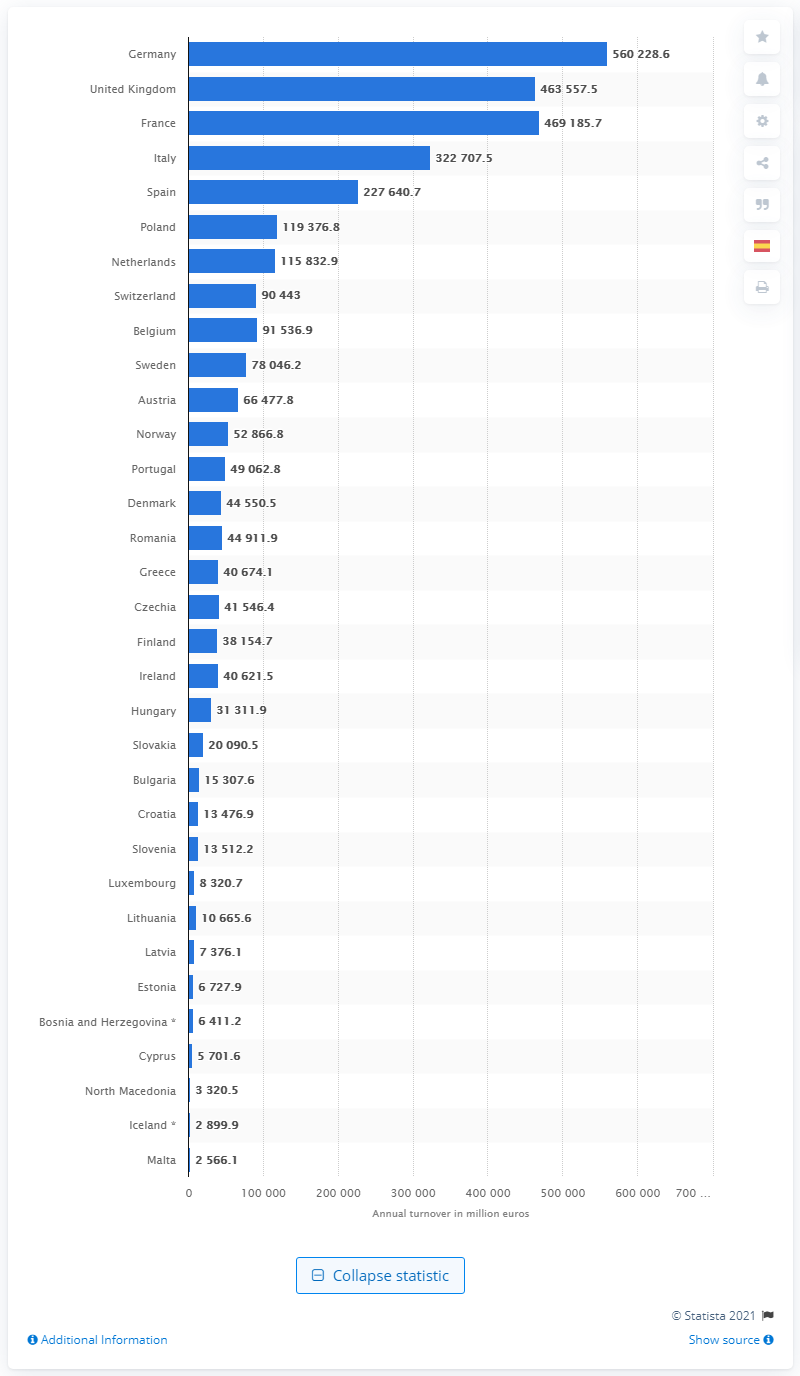Give some essential details in this illustration. In 2017, the turnover of the German retail trade was 560,228.6 million euros. 